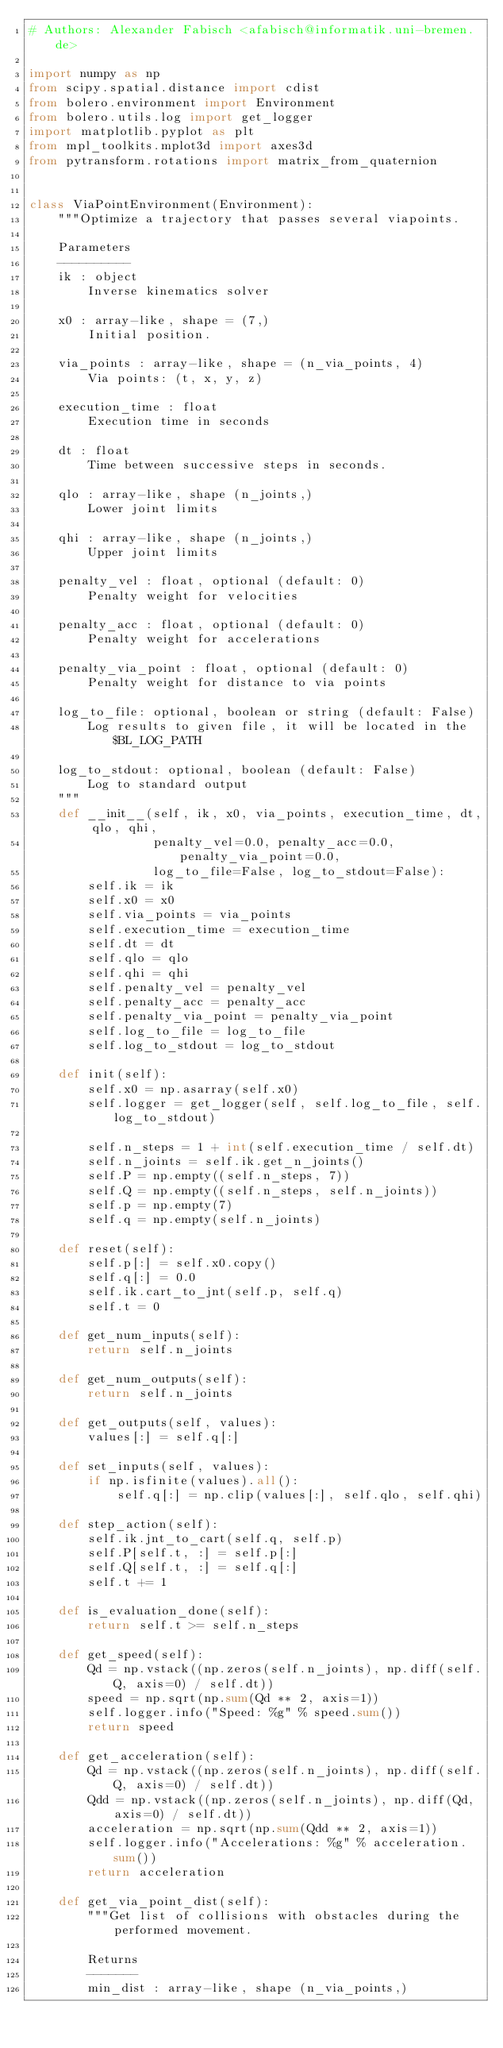Convert code to text. <code><loc_0><loc_0><loc_500><loc_500><_Python_># Authors: Alexander Fabisch <afabisch@informatik.uni-bremen.de>

import numpy as np
from scipy.spatial.distance import cdist
from bolero.environment import Environment
from bolero.utils.log import get_logger
import matplotlib.pyplot as plt
from mpl_toolkits.mplot3d import axes3d
from pytransform.rotations import matrix_from_quaternion


class ViaPointEnvironment(Environment):
    """Optimize a trajectory that passes several viapoints.

    Parameters
    ----------
    ik : object
        Inverse kinematics solver

    x0 : array-like, shape = (7,)
        Initial position.

    via_points : array-like, shape = (n_via_points, 4)
        Via points: (t, x, y, z)

    execution_time : float
        Execution time in seconds

    dt : float
        Time between successive steps in seconds.

    qlo : array-like, shape (n_joints,)
        Lower joint limits

    qhi : array-like, shape (n_joints,)
        Upper joint limits

    penalty_vel : float, optional (default: 0)
        Penalty weight for velocities

    penalty_acc : float, optional (default: 0)
        Penalty weight for accelerations

    penalty_via_point : float, optional (default: 0)
        Penalty weight for distance to via points

    log_to_file: optional, boolean or string (default: False)
        Log results to given file, it will be located in the $BL_LOG_PATH

    log_to_stdout: optional, boolean (default: False)
        Log to standard output
    """
    def __init__(self, ik, x0, via_points, execution_time, dt, qlo, qhi,
                 penalty_vel=0.0, penalty_acc=0.0, penalty_via_point=0.0,
                 log_to_file=False, log_to_stdout=False):
        self.ik = ik
        self.x0 = x0
        self.via_points = via_points
        self.execution_time = execution_time
        self.dt = dt
        self.qlo = qlo
        self.qhi = qhi
        self.penalty_vel = penalty_vel
        self.penalty_acc = penalty_acc
        self.penalty_via_point = penalty_via_point
        self.log_to_file = log_to_file
        self.log_to_stdout = log_to_stdout

    def init(self):
        self.x0 = np.asarray(self.x0)
        self.logger = get_logger(self, self.log_to_file, self.log_to_stdout)

        self.n_steps = 1 + int(self.execution_time / self.dt)
        self.n_joints = self.ik.get_n_joints()
        self.P = np.empty((self.n_steps, 7))
        self.Q = np.empty((self.n_steps, self.n_joints))
        self.p = np.empty(7)
        self.q = np.empty(self.n_joints)

    def reset(self):
        self.p[:] = self.x0.copy()
        self.q[:] = 0.0
        self.ik.cart_to_jnt(self.p, self.q)
        self.t = 0

    def get_num_inputs(self):
        return self.n_joints

    def get_num_outputs(self):
        return self.n_joints

    def get_outputs(self, values):
        values[:] = self.q[:]

    def set_inputs(self, values):
        if np.isfinite(values).all():
            self.q[:] = np.clip(values[:], self.qlo, self.qhi)

    def step_action(self):
        self.ik.jnt_to_cart(self.q, self.p)
        self.P[self.t, :] = self.p[:]
        self.Q[self.t, :] = self.q[:]
        self.t += 1

    def is_evaluation_done(self):
        return self.t >= self.n_steps

    def get_speed(self):
        Qd = np.vstack((np.zeros(self.n_joints), np.diff(self.Q, axis=0) / self.dt))
        speed = np.sqrt(np.sum(Qd ** 2, axis=1))
        self.logger.info("Speed: %g" % speed.sum())
        return speed

    def get_acceleration(self):
        Qd = np.vstack((np.zeros(self.n_joints), np.diff(self.Q, axis=0) / self.dt))
        Qdd = np.vstack((np.zeros(self.n_joints), np.diff(Qd, axis=0) / self.dt))
        acceleration = np.sqrt(np.sum(Qdd ** 2, axis=1))
        self.logger.info("Accelerations: %g" % acceleration.sum())
        return acceleration

    def get_via_point_dist(self):
        """Get list of collisions with obstacles during the performed movement.

        Returns
        -------
        min_dist : array-like, shape (n_via_points,)</code> 